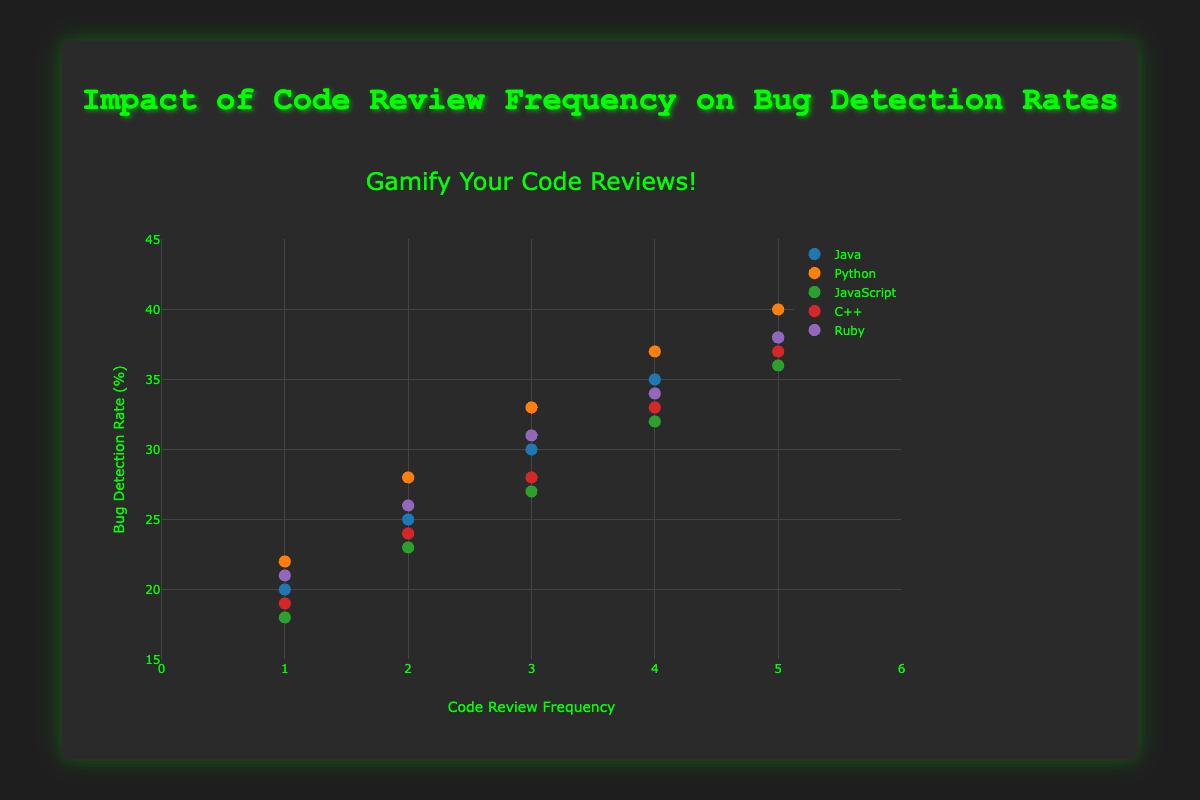What is the title of the figure? The title is located at the top center of the figure and is styled in a larger, different color font. It reads: "Impact of Code Review Frequency on Bug Detection Rates"
Answer: Impact of Code Review Frequency on Bug Detection Rates Which programming language shows the highest bug detection rate when the review frequency is 5? By comparing the bug detection rates of all the programming languages when the review frequency is 5, it is observed that Python has the highest rate at 40%.
Answer: Python How does the bug detection rate for Java change as the review frequency increases from 1 to 5? From the scatter plot, observing the Java data points, the bug detection rate increases as follows: 20%, 25%, 30%, 35%, and 38%.
Answer: The rate increases gradually What is the difference in bug detection rates between Java and JavaScript when the review frequency is 2? At a review frequency of 2, the bug detection rate for Java is 25% and for JavaScript is 23%. The difference is 25% - 23% = 2%.
Answer: 2% Which programming language has the least bug detection rate at a review frequency of 1? From the plot, comparing all data points at a review frequency of 1, JavaScript has the lowest bug detection rate, which is 18%.
Answer: JavaScript What is the average bug detection rate for Ruby across all review frequencies? The bug detection rates for Ruby at frequencies 1 to 5 are 21%, 26%, 31%, 34%, and 38%. The average is calculated as (21 + 26 + 31 + 34 + 38) / 5 = 30%.
Answer: 30% For Python, what is the increase in bug detection rate from a review frequency of 2 to 4? The bug detection rates for Python are 28% at frequency 2 and 37% at frequency 4. The increase is 37% - 28% = 9%.
Answer: 9% Compare the bug detection rates for all languages at a review frequency of 3. Which language has the median rate? The bug detection rates for Java, Python, JavaScript, C++, and Ruby at review frequency 3 are 30%, 33%, 27%, 28%, and 31%, respectively. Ordering them: 27%, 28%, 30%, 31%, 33%. The median rate is 30%, which belongs to Java.
Answer: Java What trend can be observed about the bug detection rate as the review frequency increases for C++? Observing the data points for C++, the bug detection rate increases progressively from 19%, 24%, 28%, 33%, to 37% as the review frequency increases from 1 to 5.
Answer: The rate increases steadily When looking at the figure, is there a noticeable pattern between review frequency and bug detection rates across all languages? Generally, as the review frequency increases from 1 to 5, the bug detection rate increases for all programming languages, showing a positive correlation between review frequency and bug detection rate.
Answer: Positive correlation between review frequency and bug detection rate 